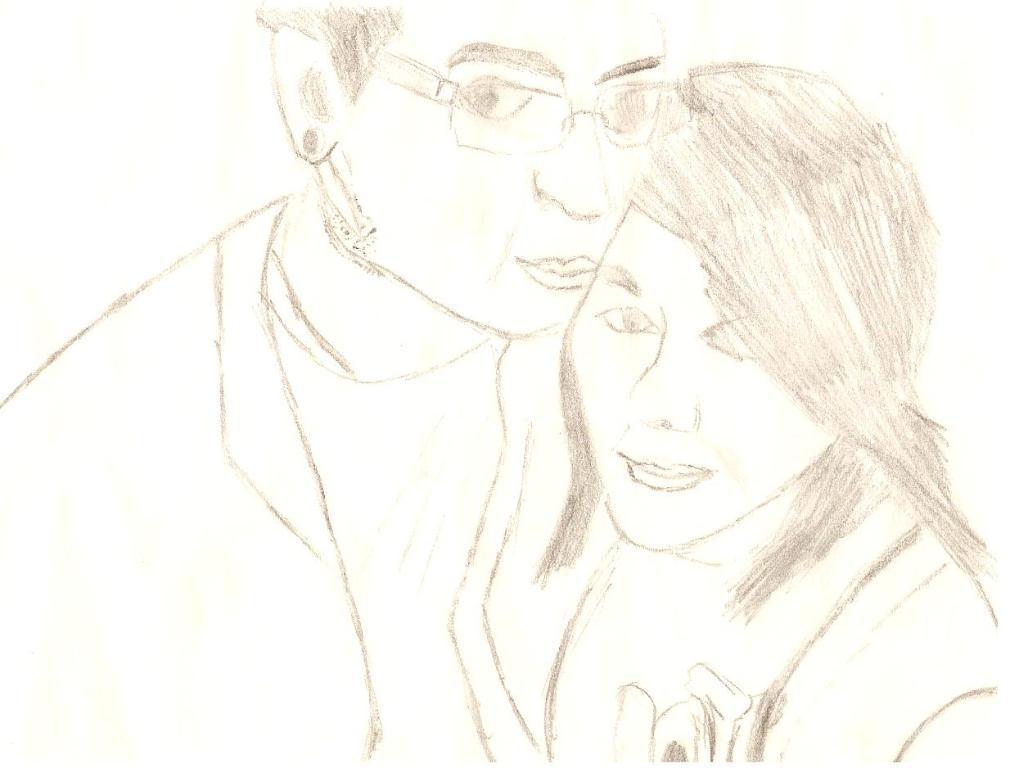Describe this image in one or two sentences. In the picture I can see drawing of a man and woman. 